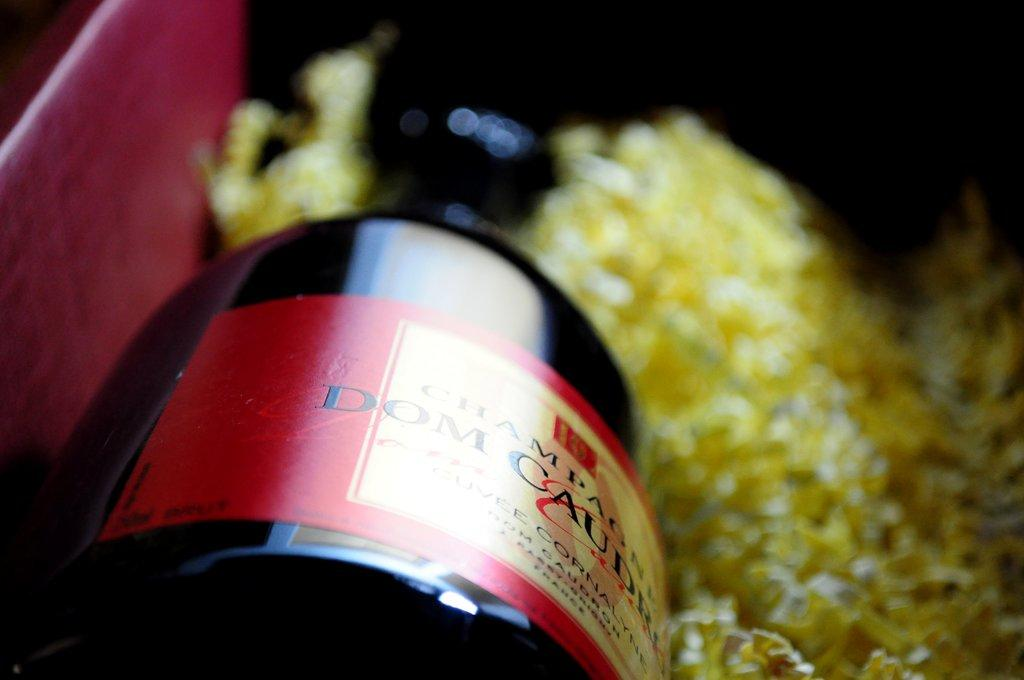Provide a one-sentence caption for the provided image. A bottle of Dom Caudru Champagne in a red box with yellow confetti type packing material. 